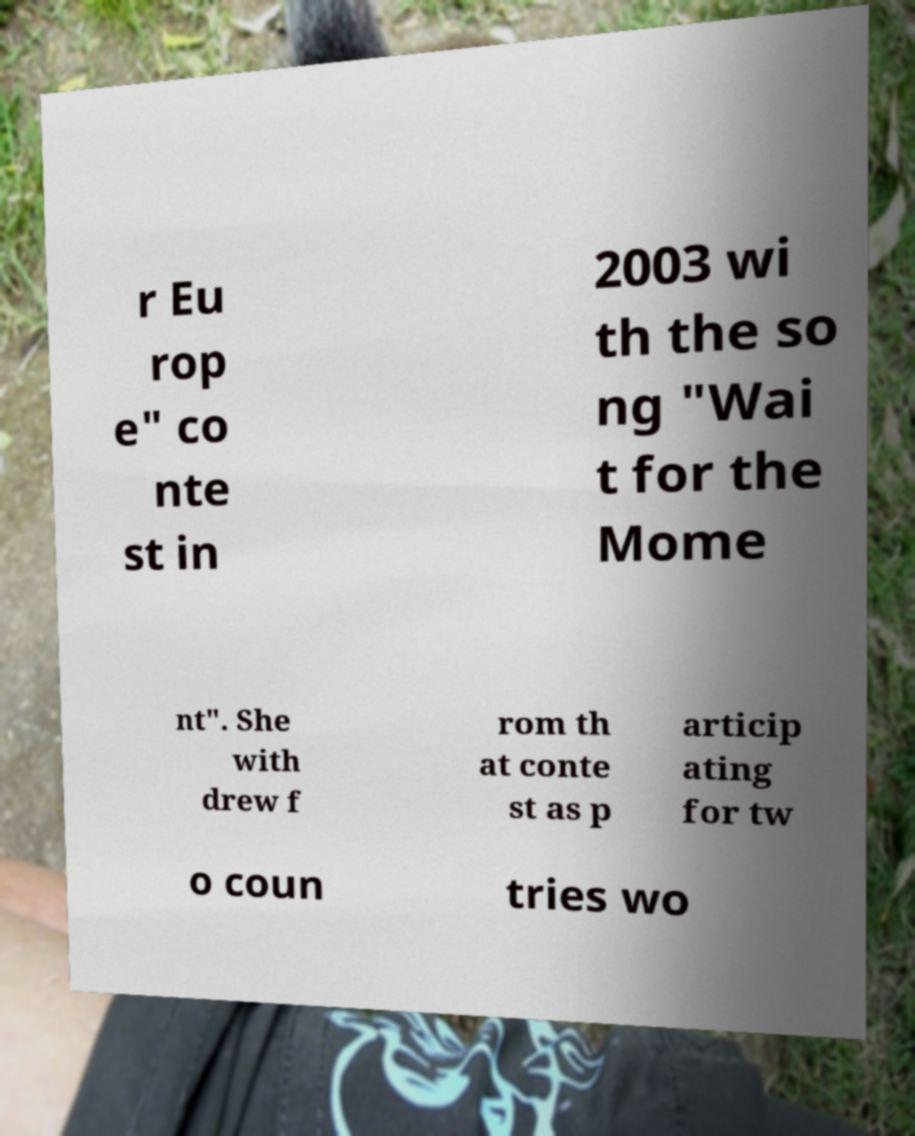Could you extract and type out the text from this image? r Eu rop e" co nte st in 2003 wi th the so ng "Wai t for the Mome nt". She with drew f rom th at conte st as p articip ating for tw o coun tries wo 